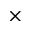<formula> <loc_0><loc_0><loc_500><loc_500>\times</formula> 